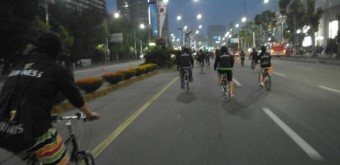What mode of transportation seems most popular in this image? Bicycling appears to be the most popular mode of transportation in this image, reflecting an environmentally friendly and health-conscious choice by the individuals present. 